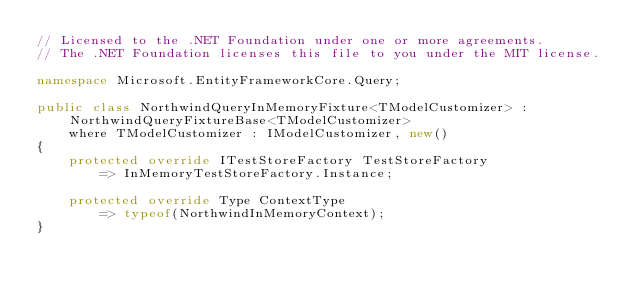<code> <loc_0><loc_0><loc_500><loc_500><_C#_>// Licensed to the .NET Foundation under one or more agreements.
// The .NET Foundation licenses this file to you under the MIT license.

namespace Microsoft.EntityFrameworkCore.Query;

public class NorthwindQueryInMemoryFixture<TModelCustomizer> : NorthwindQueryFixtureBase<TModelCustomizer>
    where TModelCustomizer : IModelCustomizer, new()
{
    protected override ITestStoreFactory TestStoreFactory
        => InMemoryTestStoreFactory.Instance;

    protected override Type ContextType
        => typeof(NorthwindInMemoryContext);
}
</code> 